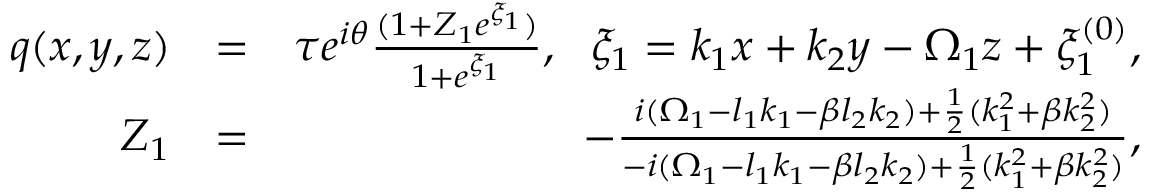<formula> <loc_0><loc_0><loc_500><loc_500>\begin{array} { r l r } { q ( x , y , z ) } & { = } & { \tau e ^ { i \theta } \frac { ( 1 + Z _ { 1 } e ^ { \xi _ { 1 } } ) } { 1 + e ^ { \xi _ { 1 } } } , \xi _ { 1 } = k _ { 1 } x + k _ { 2 } y - \Omega _ { 1 } z + \xi _ { 1 } ^ { ( 0 ) } , } \\ { Z _ { 1 } } & { = } & { - \frac { i ( \Omega _ { 1 } - l _ { 1 } k _ { 1 } - \beta l _ { 2 } k _ { 2 } ) + \frac { 1 } { 2 } ( k _ { 1 } ^ { 2 } + \beta k _ { 2 } ^ { 2 } ) } { - i ( \Omega _ { 1 } - l _ { 1 } k _ { 1 } - \beta l _ { 2 } k _ { 2 } ) + \frac { 1 } { 2 } ( k _ { 1 } ^ { 2 } + \beta k _ { 2 } ^ { 2 } ) } , } \end{array}</formula> 